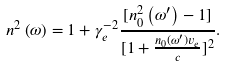Convert formula to latex. <formula><loc_0><loc_0><loc_500><loc_500>n ^ { 2 } \left ( \omega \right ) = 1 + \gamma _ { e } ^ { - 2 } \frac { [ n _ { 0 } ^ { 2 } \left ( \omega ^ { \prime } \right ) - 1 ] } { [ 1 + \frac { n _ { 0 } \left ( \omega ^ { \prime } \right ) v _ { e } } { c } ] ^ { 2 } } .</formula> 